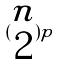<formula> <loc_0><loc_0><loc_500><loc_500>( \begin{matrix} n \\ 2 \end{matrix} ) p</formula> 